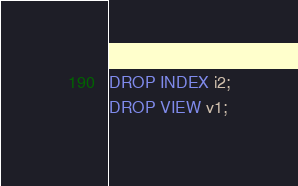<code> <loc_0><loc_0><loc_500><loc_500><_SQL_>DROP INDEX i2;
DROP VIEW v1;</code> 